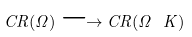Convert formula to latex. <formula><loc_0><loc_0><loc_500><loc_500>C R ( \Omega ) \longrightarrow C R ( \Omega \ K )</formula> 